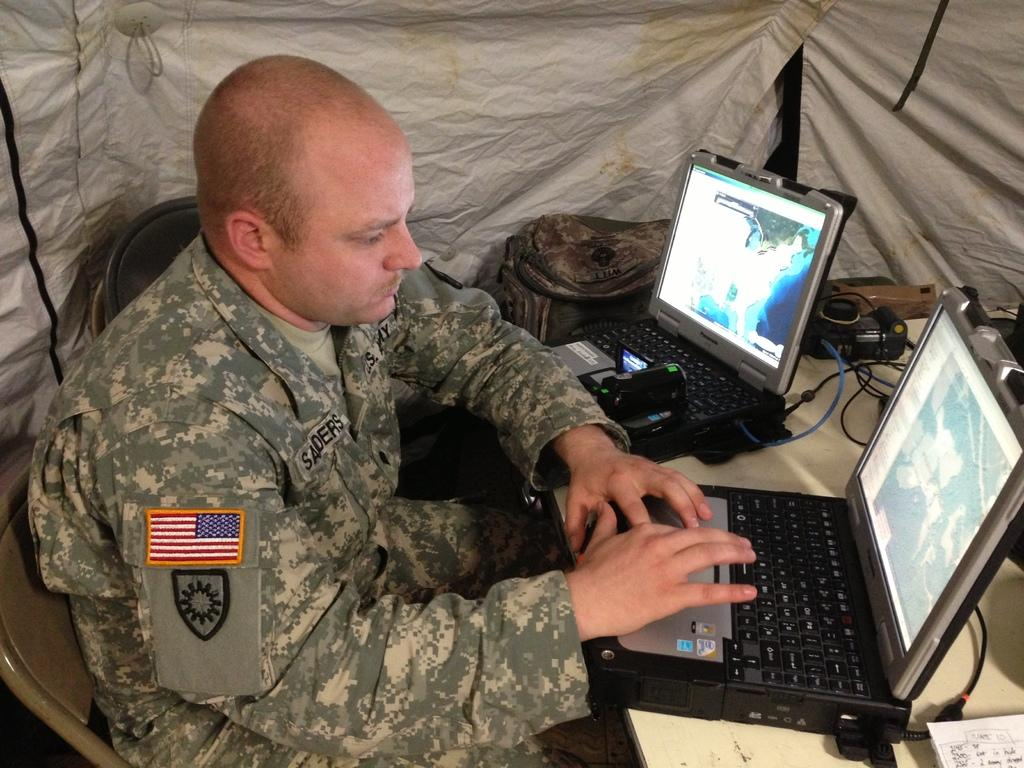<image>
Share a concise interpretation of the image provided. Name of the American soldier is Saders and he is typing 